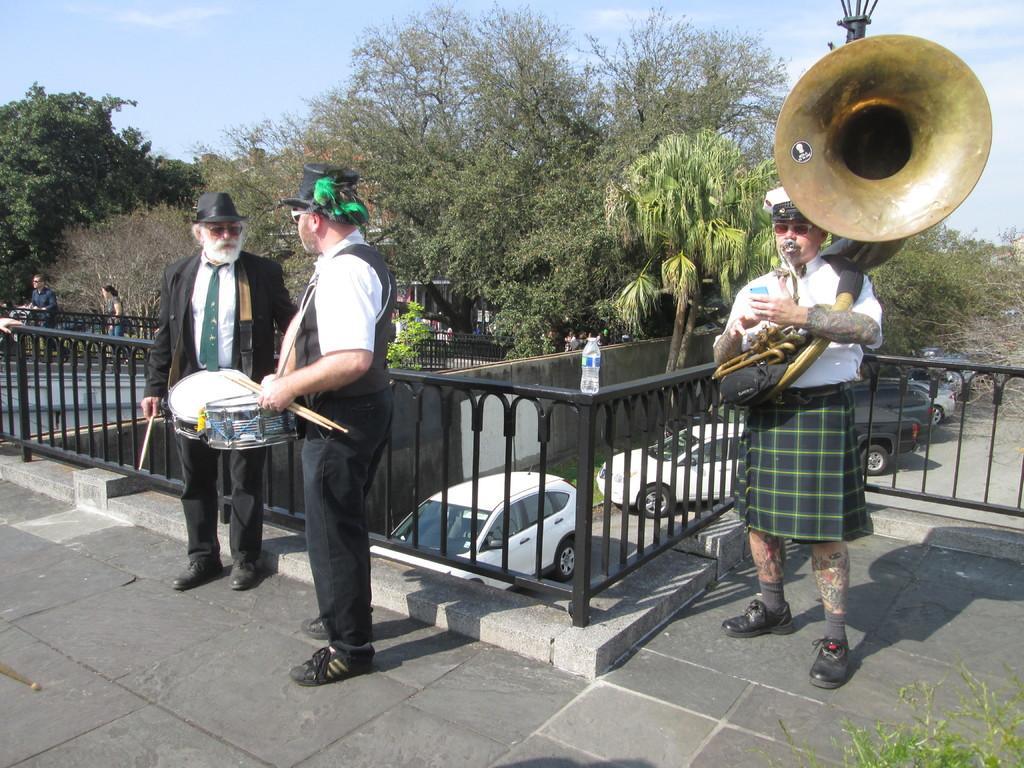How would you summarize this image in a sentence or two? This is a picture taken in the outdoor, the man standing were playing the music item and the two man in black blazer were playing the drums and holding the drumsticks. Background of this people is a tree with the sky. Background of this people there is a Black fencing on top of it there is a water bottle. 